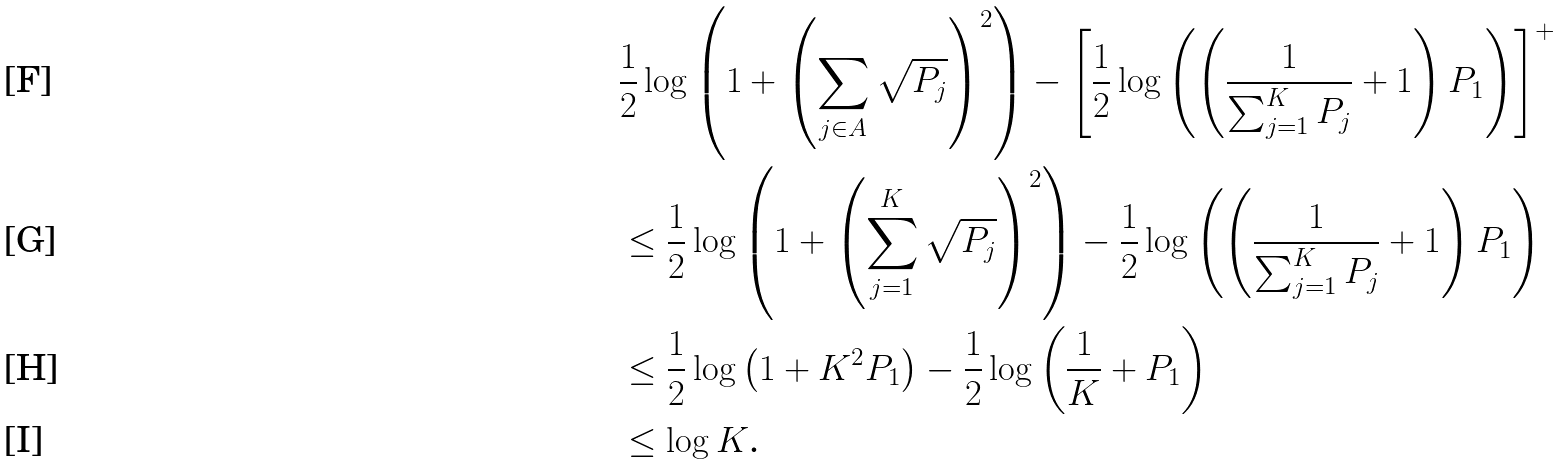<formula> <loc_0><loc_0><loc_500><loc_500>& \frac { 1 } { 2 } \log \left ( 1 + \left ( \sum _ { j \in A } \sqrt { P _ { j } } \right ) ^ { 2 } \right ) - \left [ \frac { 1 } { 2 } \log \left ( \left ( \frac { 1 } { \sum _ { j = 1 } ^ { K } P _ { j } } + 1 \right ) P _ { 1 } \right ) \right ] ^ { + } \\ & \leq \frac { 1 } { 2 } \log \left ( 1 + \left ( \sum _ { j = 1 } ^ { K } \sqrt { P _ { j } } \right ) ^ { 2 } \right ) - \frac { 1 } { 2 } \log \left ( \left ( \frac { 1 } { \sum _ { j = 1 } ^ { K } P _ { j } } + 1 \right ) P _ { 1 } \right ) \\ & \leq \frac { 1 } { 2 } \log \left ( 1 + K ^ { 2 } P _ { 1 } \right ) - \frac { 1 } { 2 } \log \left ( \frac { 1 } { K } + P _ { 1 } \right ) \\ & \leq \log K \text  .</formula> 